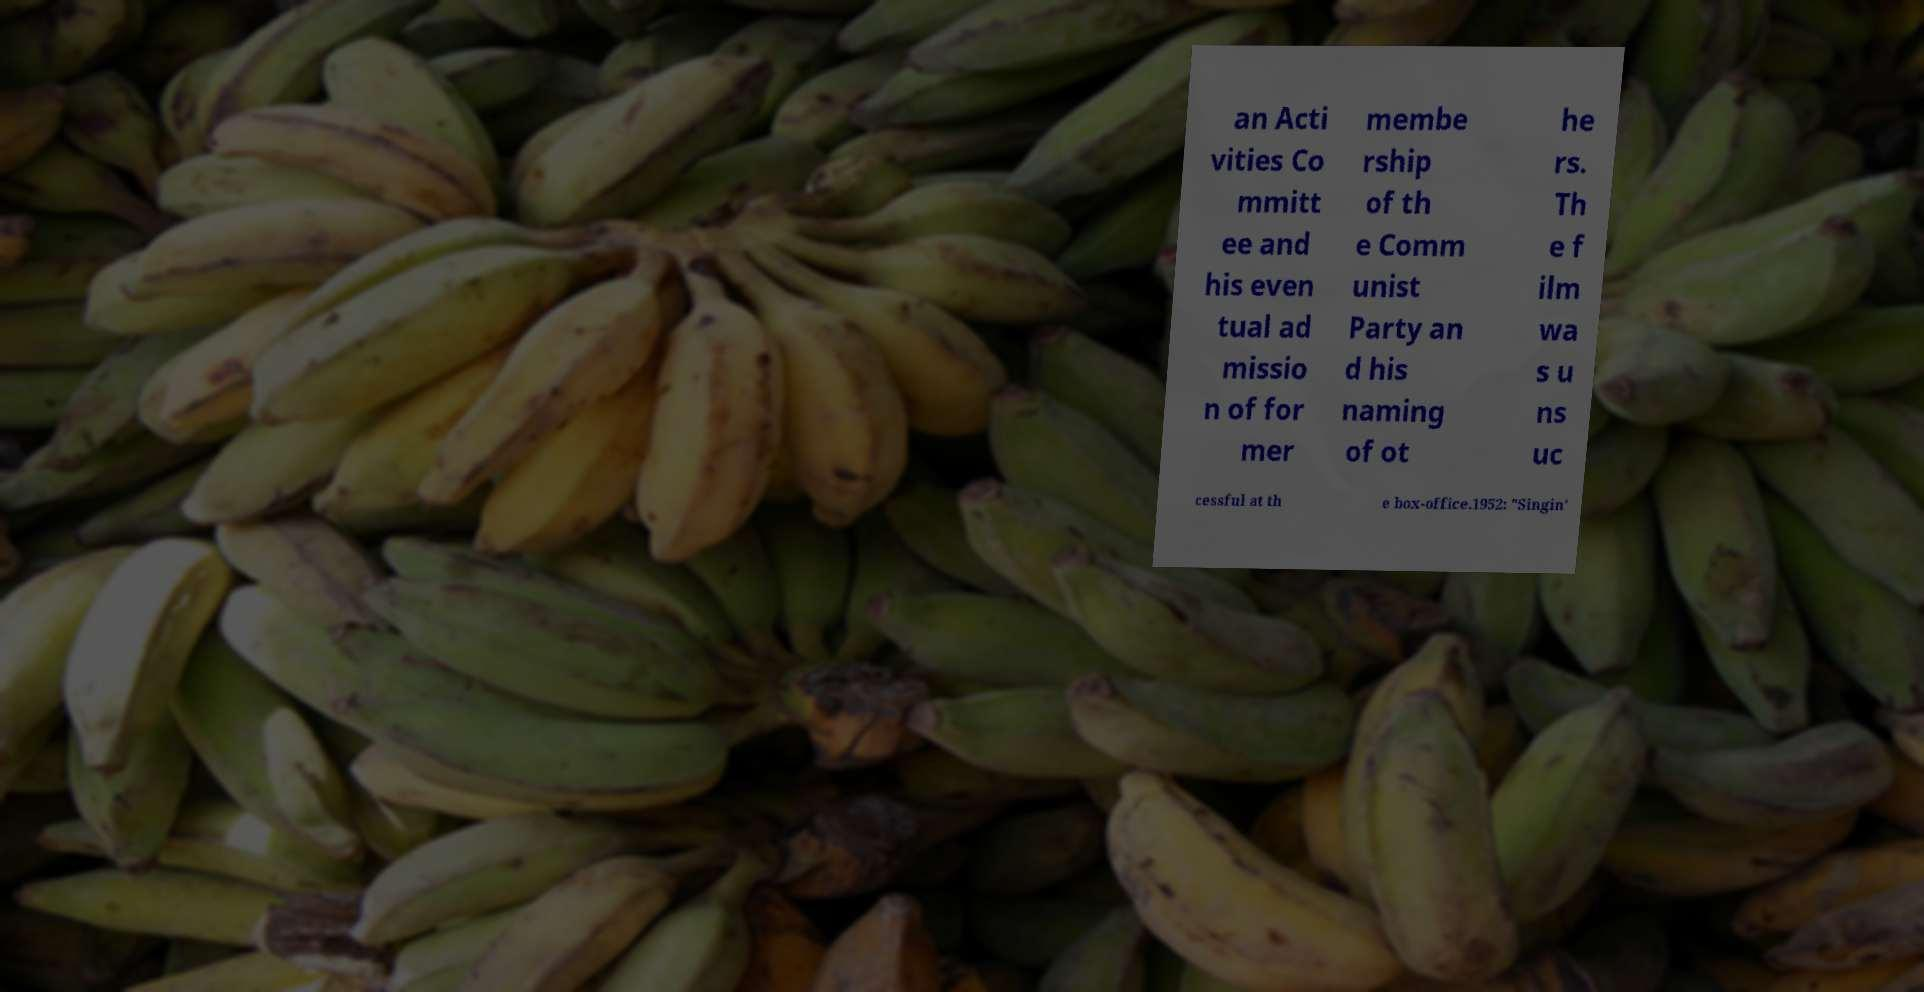Please read and relay the text visible in this image. What does it say? an Acti vities Co mmitt ee and his even tual ad missio n of for mer membe rship of th e Comm unist Party an d his naming of ot he rs. Th e f ilm wa s u ns uc cessful at th e box-office.1952: "Singin' 